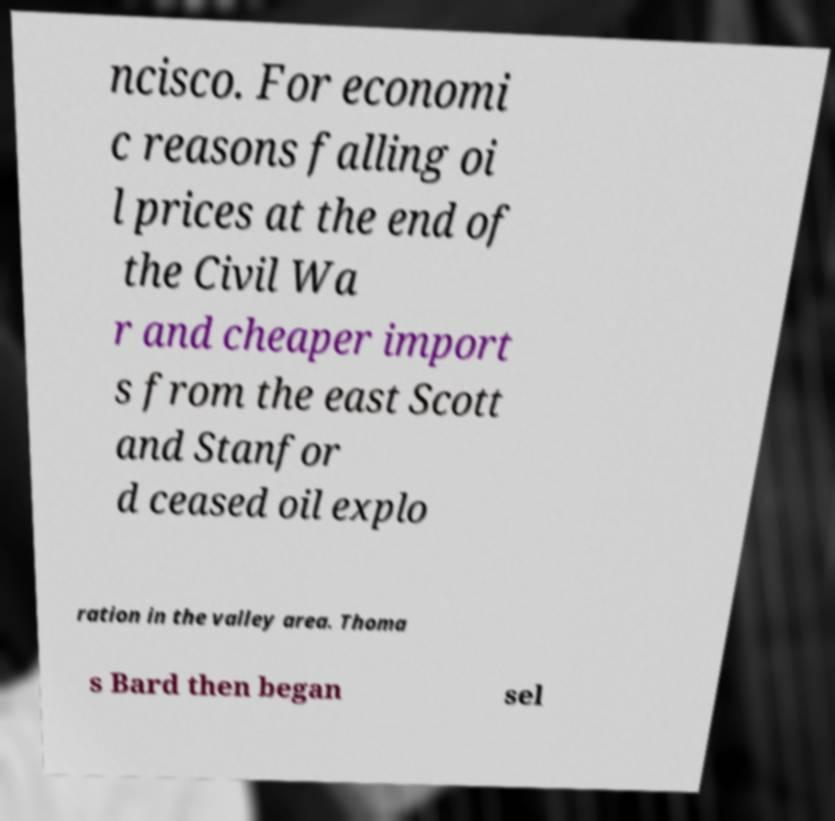There's text embedded in this image that I need extracted. Can you transcribe it verbatim? ncisco. For economi c reasons falling oi l prices at the end of the Civil Wa r and cheaper import s from the east Scott and Stanfor d ceased oil explo ration in the valley area. Thoma s Bard then began sel 